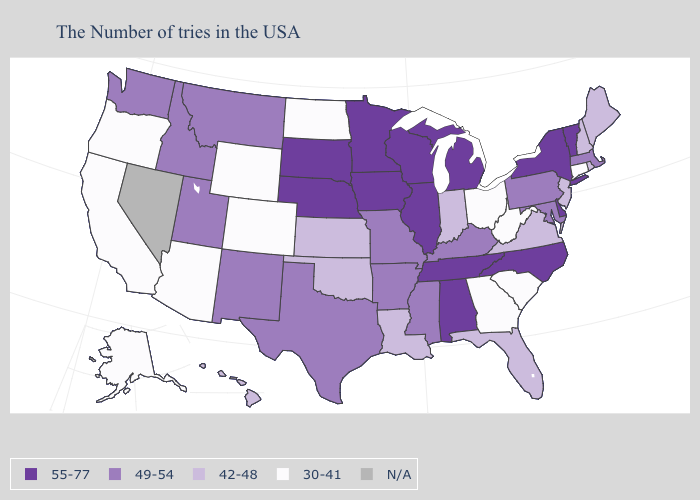What is the highest value in the USA?
Quick response, please. 55-77. What is the highest value in the USA?
Answer briefly. 55-77. What is the value of Mississippi?
Keep it brief. 49-54. Which states have the lowest value in the West?
Write a very short answer. Wyoming, Colorado, Arizona, California, Oregon, Alaska. Which states have the lowest value in the West?
Write a very short answer. Wyoming, Colorado, Arizona, California, Oregon, Alaska. What is the lowest value in the West?
Short answer required. 30-41. Among the states that border Washington , does Idaho have the highest value?
Short answer required. Yes. What is the value of South Carolina?
Short answer required. 30-41. What is the value of Vermont?
Write a very short answer. 55-77. What is the highest value in the MidWest ?
Quick response, please. 55-77. Name the states that have a value in the range 49-54?
Concise answer only. Massachusetts, Maryland, Pennsylvania, Kentucky, Mississippi, Missouri, Arkansas, Texas, New Mexico, Utah, Montana, Idaho, Washington. Does the map have missing data?
Keep it brief. Yes. Is the legend a continuous bar?
Quick response, please. No. What is the lowest value in the USA?
Quick response, please. 30-41. 